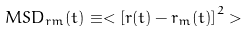Convert formula to latex. <formula><loc_0><loc_0><loc_500><loc_500>M S D _ { r m } ( t ) \equiv < \left [ r ( t ) - r _ { m } ( t ) \right ] ^ { 2 } ></formula> 